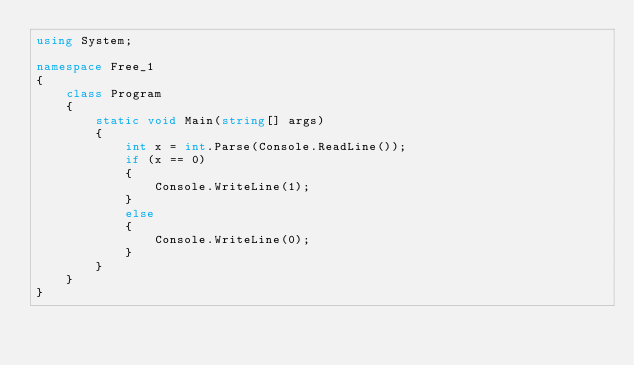<code> <loc_0><loc_0><loc_500><loc_500><_C#_>using System;

namespace Free_1
{
    class Program
    {
        static void Main(string[] args)
        {
            int x = int.Parse(Console.ReadLine());
            if (x == 0)
            {
                Console.WriteLine(1);
            }
            else
            {
                Console.WriteLine(0);
            }
        }
    }
}</code> 